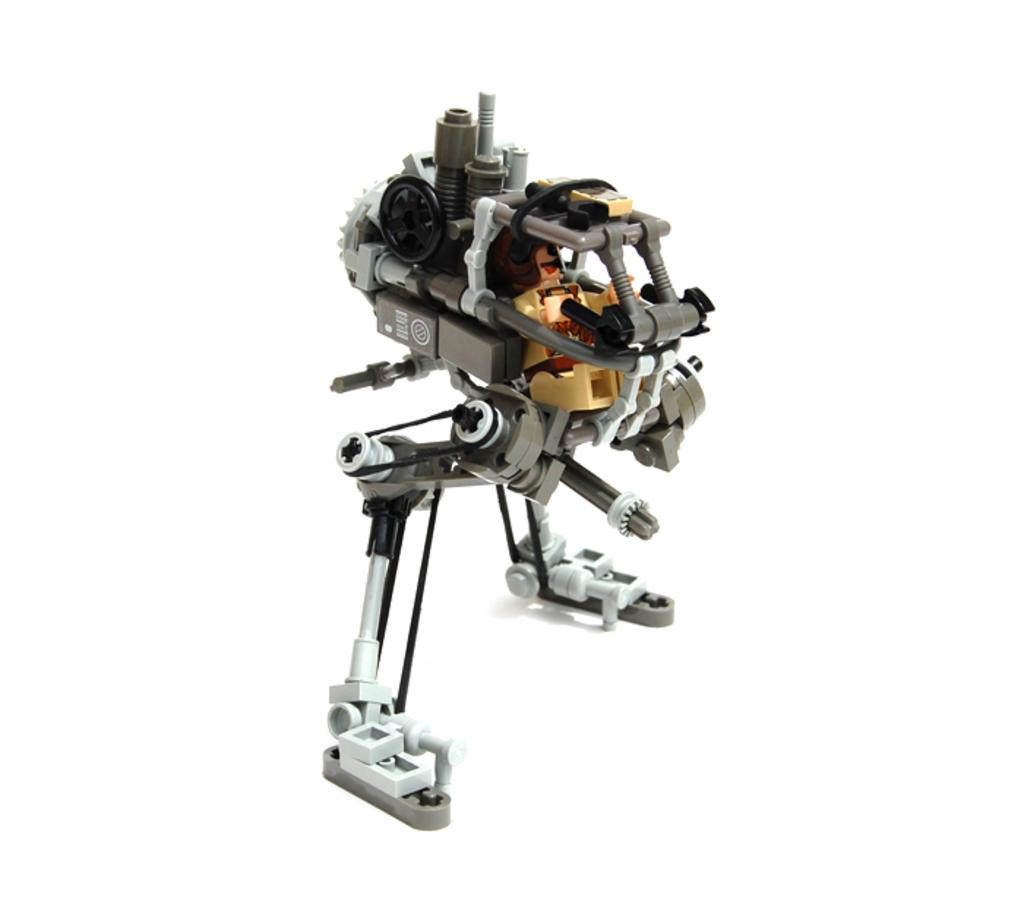What object in the image can be considered a toy? There is a toy in the image. What historical event is depicted on the toy in the image? There is no historical event depicted on the toy in the image, as the fact provided does not give any information about the toy's design or appearance. 